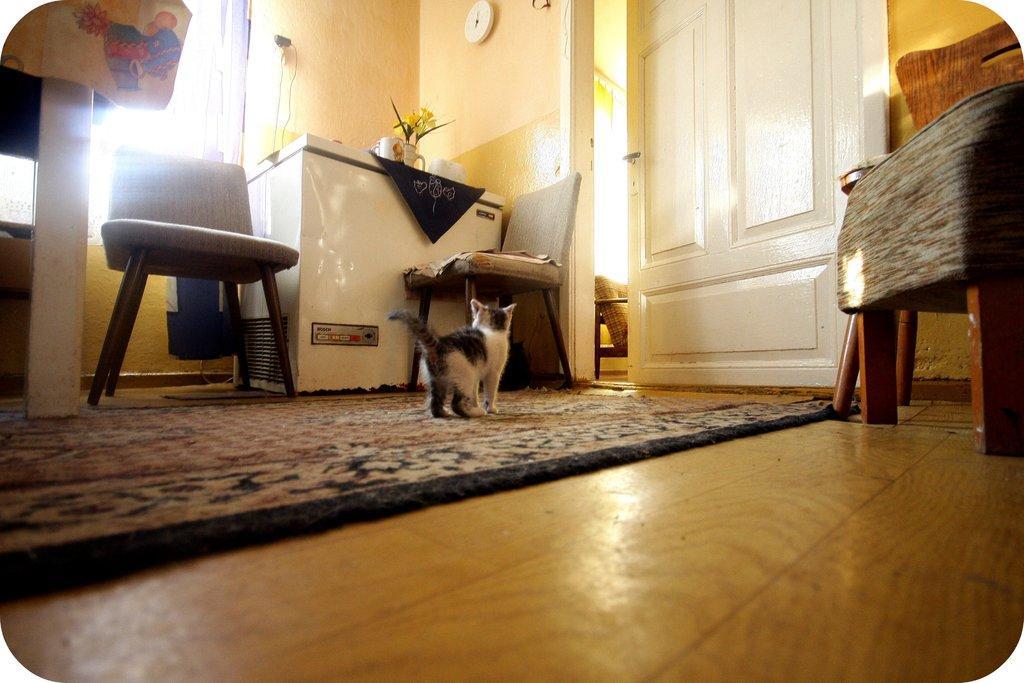How would you summarize this image in a sentence or two? In the center of the image there is a cat who is standing on the carpet. On the top left corner there is a table which contains a cloth, beside it there is a chair and a machine. On the top we can see a clock which is hang to a wall. On the right there is a chair, beside it there is a door. 